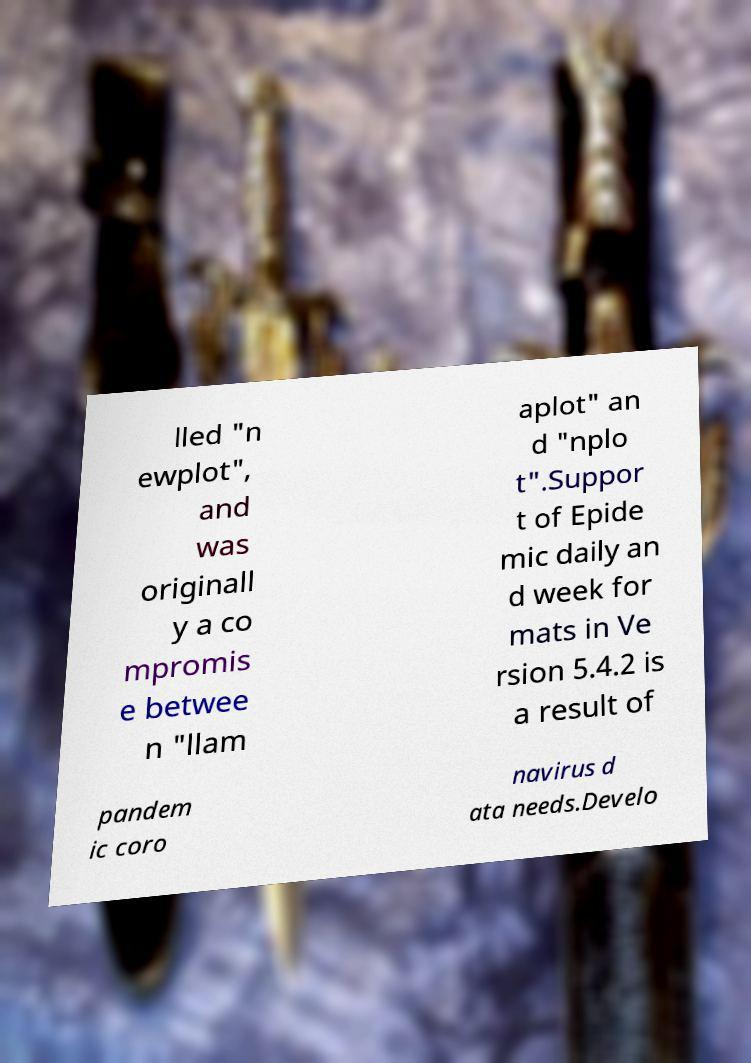Please identify and transcribe the text found in this image. lled "n ewplot", and was originall y a co mpromis e betwee n "llam aplot" an d "nplo t".Suppor t of Epide mic daily an d week for mats in Ve rsion 5.4.2 is a result of pandem ic coro navirus d ata needs.Develo 